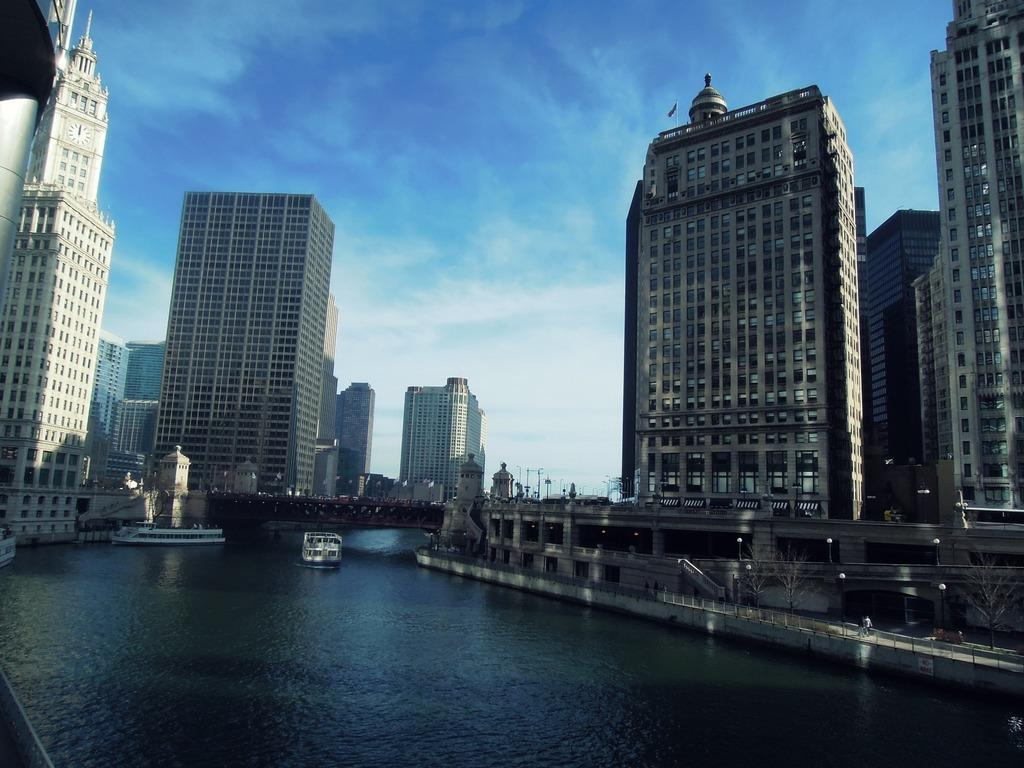What type of structures can be seen in the image? There are buildings in the image. What is the purpose of the structure that connects the two land areas in the image? There is a bridge in the image that serves to connect the two land areas. What type of vehicles are present in the image? There are boats in the image. What can be used to illuminate the scene in the image? There are lights in the image. Are there any human figures present in the image? Yes, there are people in the image. What natural element is visible in the image? There is water visible in the image. What is visible in the sky at the top of the image? Clouds are present in the sky at the top of the image. What type of reward is being given to the servant in the image? There is no reward or servant present in the image. How does the digestion process of the people in the image appear to be affected by the scene? There is no information about the digestion process of the people in the image, as the focus is on the structures, vehicles, and natural elements present. 